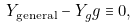<formula> <loc_0><loc_0><loc_500><loc_500>Y _ { \text {general} } - Y _ { g } g \equiv 0 ,</formula> 